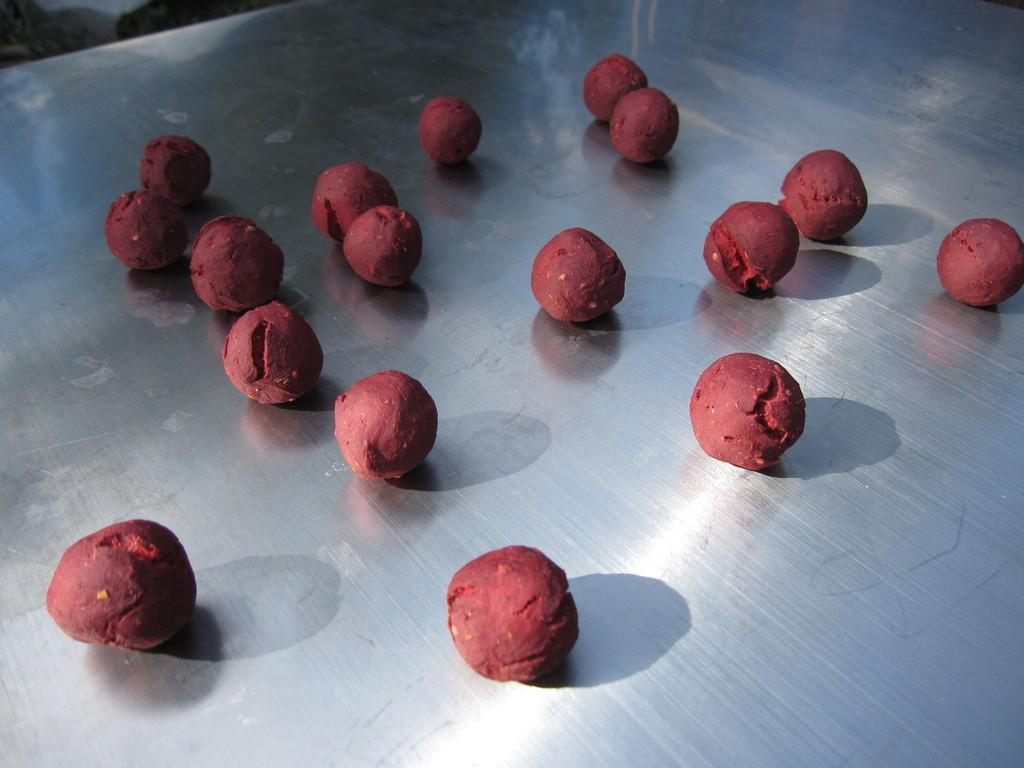What is the color of the surface in the image? The surface in the image is silver-colored. What objects are on the silver-colored surface? There are balls on the silver-colored surface. What color are the balls on the surface? The balls on the surface are red in color. How does the thread interact with the balls on the silver-colored surface? There is no thread present in the image, so it cannot interact with the balls on the surface. 